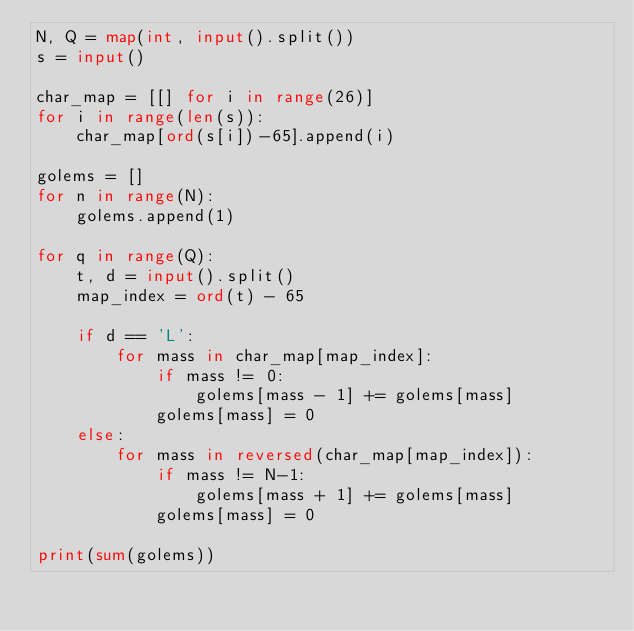<code> <loc_0><loc_0><loc_500><loc_500><_Python_>N, Q = map(int, input().split())
s = input()

char_map = [[] for i in range(26)]
for i in range(len(s)):
    char_map[ord(s[i])-65].append(i)

golems = []
for n in range(N):
    golems.append(1)

for q in range(Q):
    t, d = input().split()
    map_index = ord(t) - 65

    if d == 'L':
        for mass in char_map[map_index]:
            if mass != 0:
                golems[mass - 1] += golems[mass]
            golems[mass] = 0
    else:
        for mass in reversed(char_map[map_index]):
            if mass != N-1:
                golems[mass + 1] += golems[mass]
            golems[mass] = 0

print(sum(golems))
</code> 